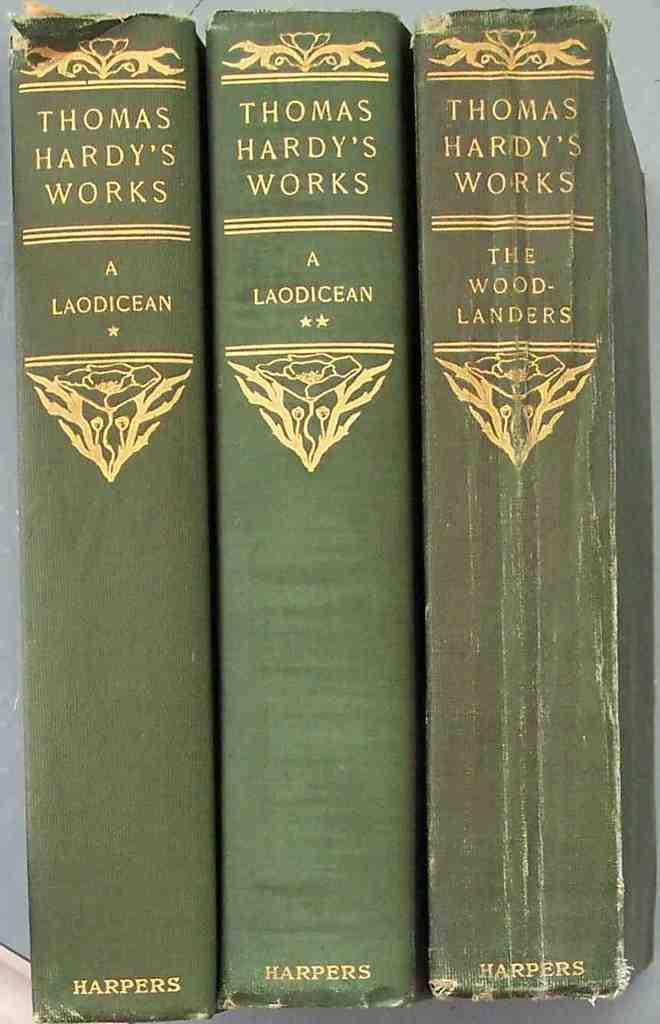<image>
Describe the image concisely. Three Thomas Hardy's works A Laodicean Harpers book. 